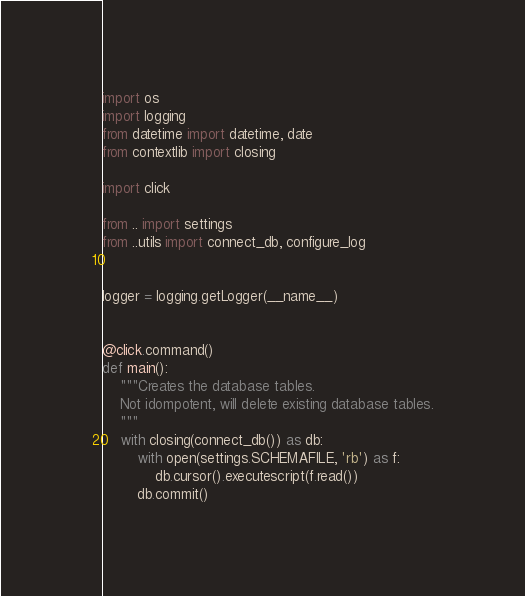<code> <loc_0><loc_0><loc_500><loc_500><_Python_>import os
import logging
from datetime import datetime, date
from contextlib import closing

import click

from .. import settings
from ..utils import connect_db, configure_log


logger = logging.getLogger(__name__)


@click.command()
def main():
    """Creates the database tables.
    Not idompotent, will delete existing database tables.
    """
    with closing(connect_db()) as db:
        with open(settings.SCHEMAFILE, 'rb') as f:
            db.cursor().executescript(f.read())
        db.commit()
</code> 